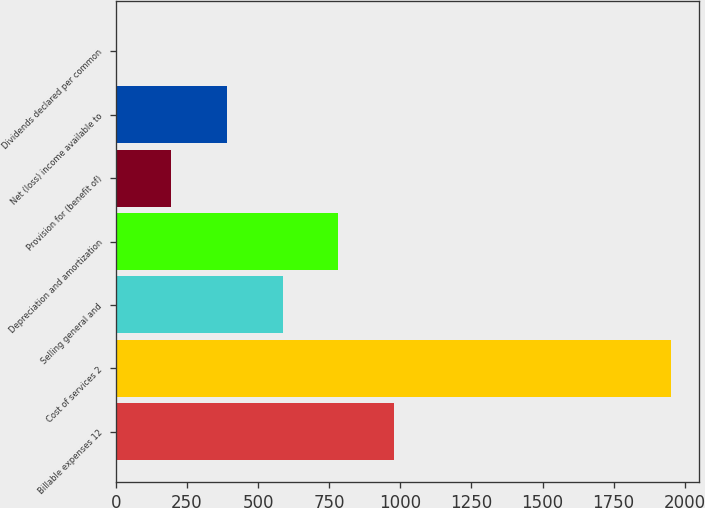Convert chart. <chart><loc_0><loc_0><loc_500><loc_500><bar_chart><fcel>Billable expenses 12<fcel>Cost of services 2<fcel>Selling general and<fcel>Depreciation and amortization<fcel>Provision for (benefit of)<fcel>Net (loss) income available to<fcel>Dividends declared per common<nl><fcel>976.53<fcel>1952.9<fcel>585.99<fcel>781.26<fcel>195.45<fcel>390.72<fcel>0.18<nl></chart> 